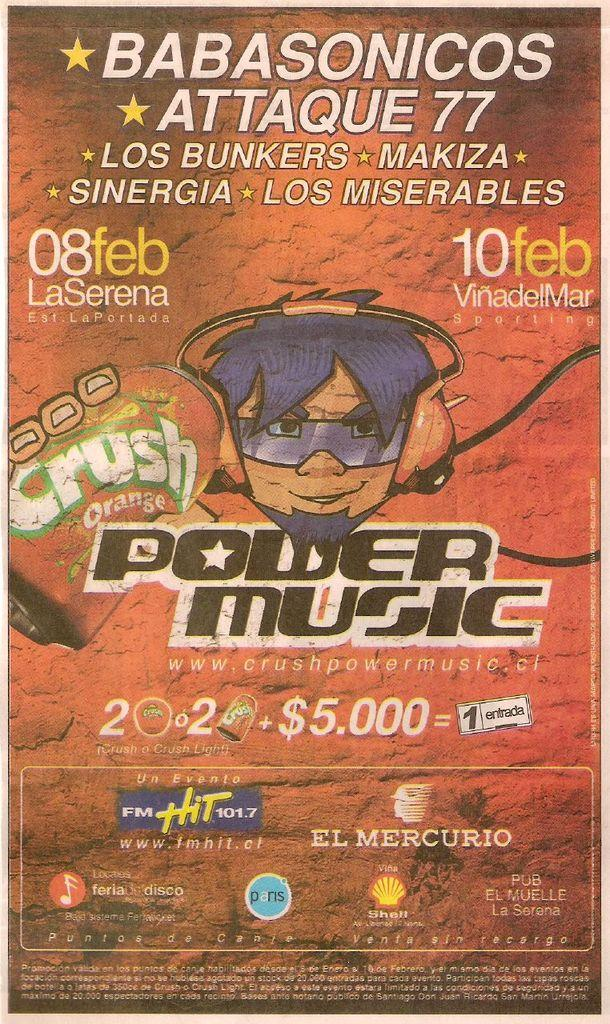What type of visual is the image? The image is a poster. Who or what is depicted in the poster? There is a person depicted in the poster. What protective gear is the person wearing? The person is wearing goggles and headphones. What object can be seen in the poster? There is a tin object in the poster. What additional design elements are present in the poster? There are symbols and text present in the poster. Can you see a frog on the floor in the poster? There is no frog or mention of a floor in the poster. 